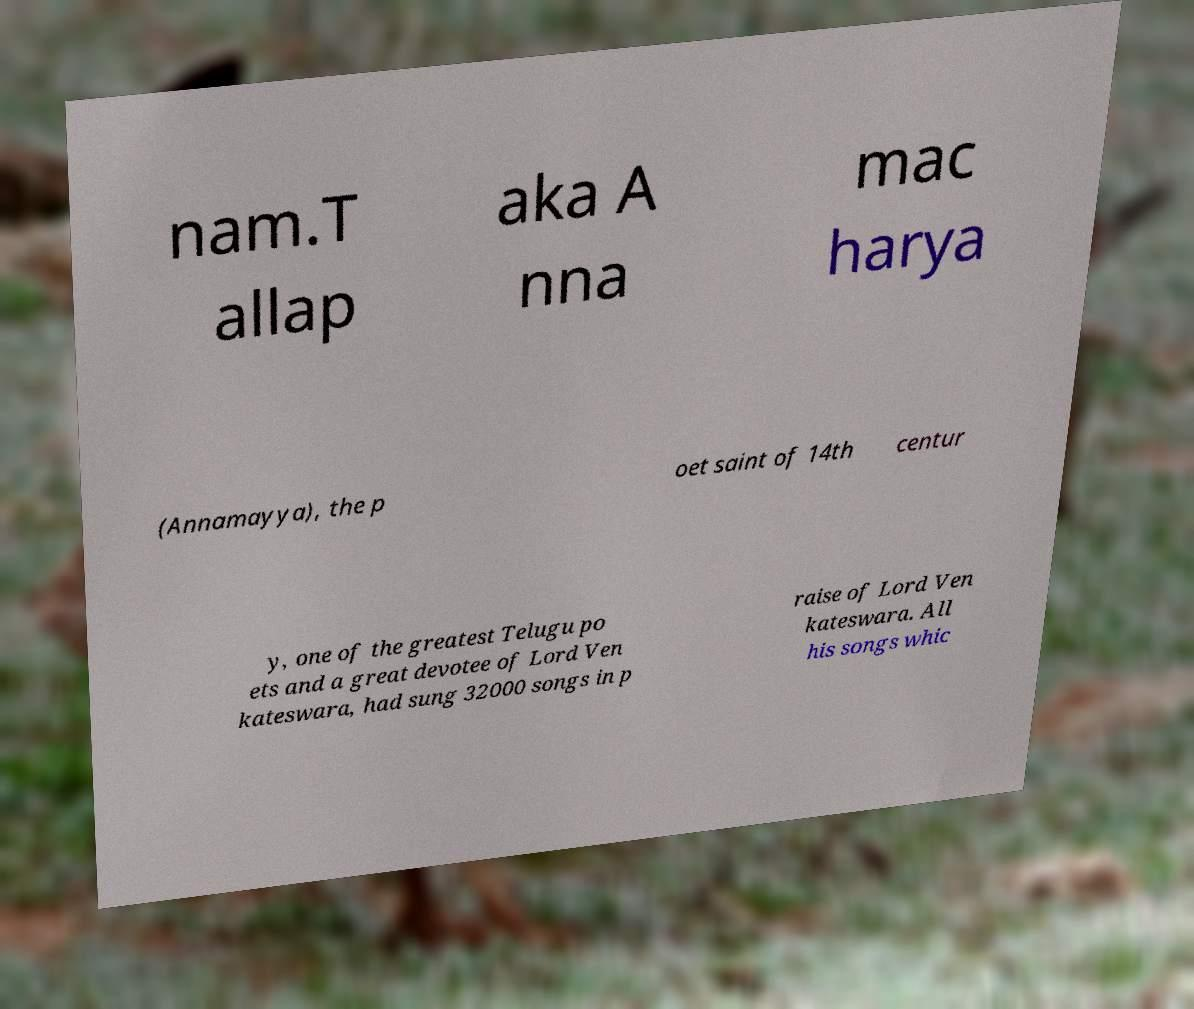Can you read and provide the text displayed in the image?This photo seems to have some interesting text. Can you extract and type it out for me? nam.T allap aka A nna mac harya (Annamayya), the p oet saint of 14th centur y, one of the greatest Telugu po ets and a great devotee of Lord Ven kateswara, had sung 32000 songs in p raise of Lord Ven kateswara. All his songs whic 